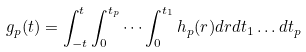<formula> <loc_0><loc_0><loc_500><loc_500>g _ { p } ( t ) = \int _ { - t } ^ { t } \int _ { 0 } ^ { t _ { p } } \cdots \int _ { 0 } ^ { t _ { 1 } } h _ { p } ( r ) d r d t _ { 1 } \dots d t _ { p }</formula> 